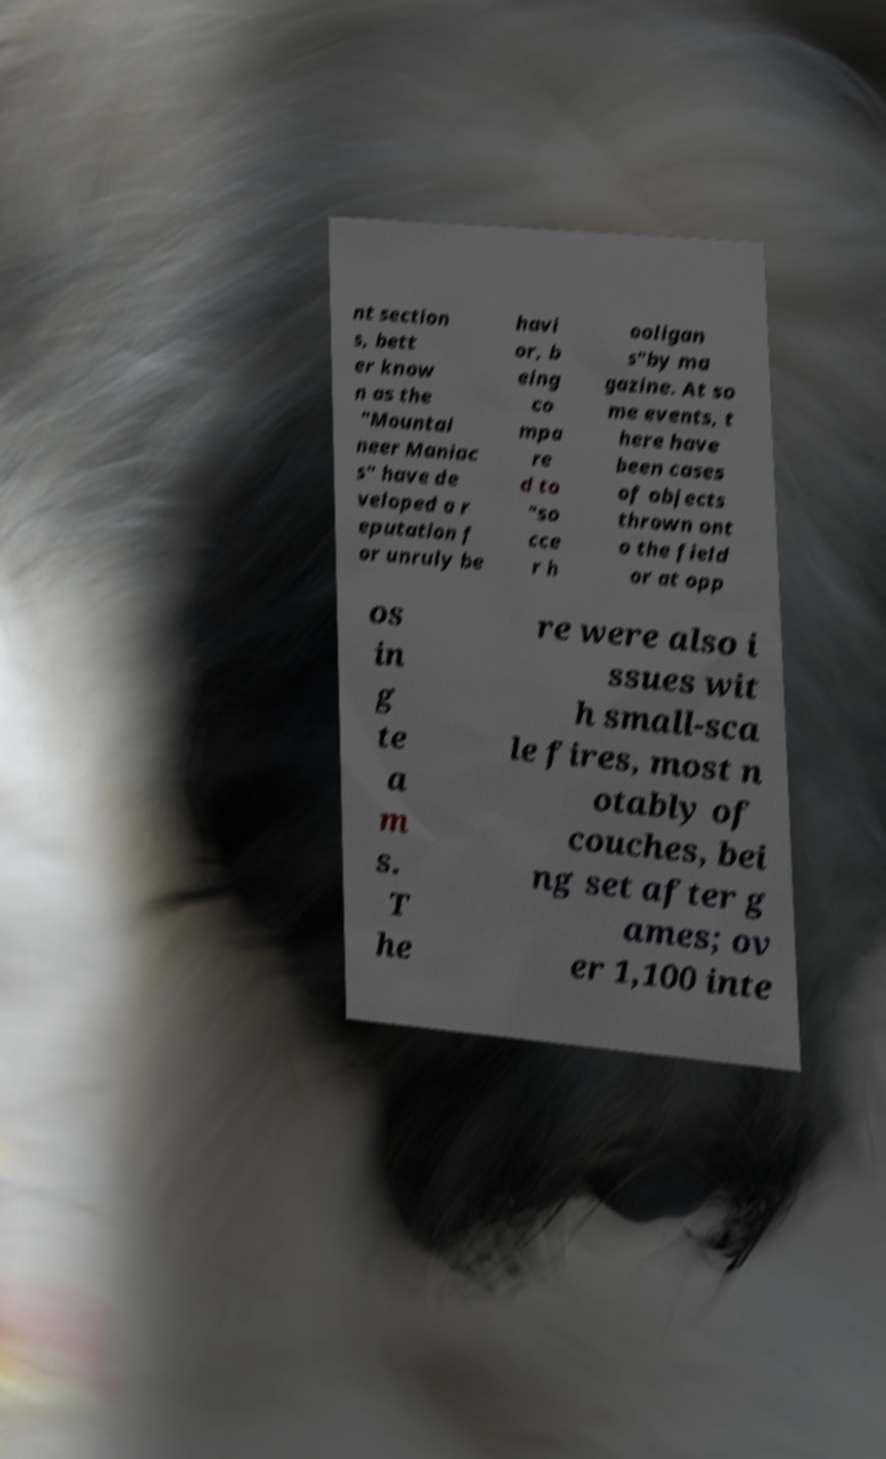There's text embedded in this image that I need extracted. Can you transcribe it verbatim? nt section s, bett er know n as the "Mountai neer Maniac s" have de veloped a r eputation f or unruly be havi or, b eing co mpa re d to "so cce r h ooligan s"by ma gazine. At so me events, t here have been cases of objects thrown ont o the field or at opp os in g te a m s. T he re were also i ssues wit h small-sca le fires, most n otably of couches, bei ng set after g ames; ov er 1,100 inte 